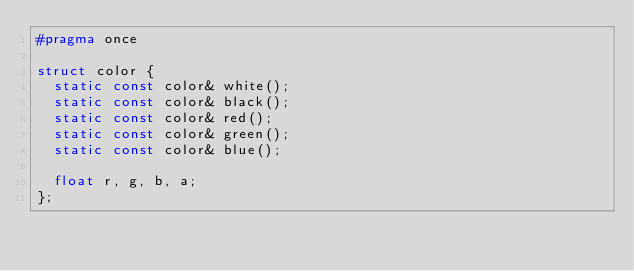<code> <loc_0><loc_0><loc_500><loc_500><_C_>#pragma once

struct color {
  static const color& white();
  static const color& black();
  static const color& red();
  static const color& green();
  static const color& blue();

  float r, g, b, a;
};


</code> 